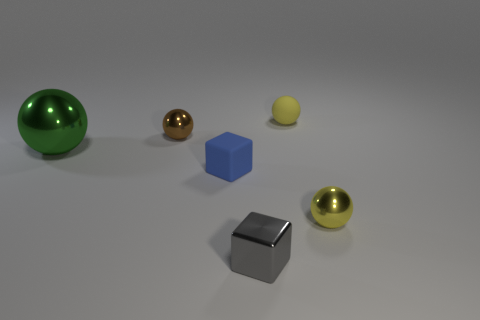Subtract all gray spheres. Subtract all red blocks. How many spheres are left? 4 Add 3 large matte things. How many objects exist? 9 Subtract all cubes. How many objects are left? 4 Subtract 0 gray cylinders. How many objects are left? 6 Subtract all tiny rubber cubes. Subtract all large objects. How many objects are left? 4 Add 2 green shiny balls. How many green shiny balls are left? 3 Add 3 tiny yellow rubber balls. How many tiny yellow rubber balls exist? 4 